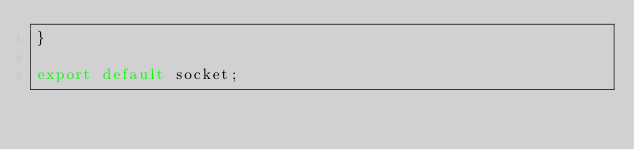Convert code to text. <code><loc_0><loc_0><loc_500><loc_500><_JavaScript_>}

export default socket;</code> 